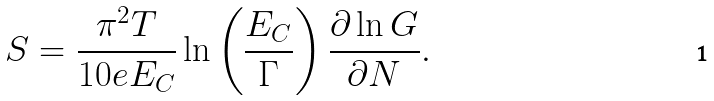<formula> <loc_0><loc_0><loc_500><loc_500>S = \frac { \pi ^ { 2 } T } { 1 0 e E _ { C } } \ln \left ( \frac { E _ { C } } { \Gamma } \right ) \frac { \partial \ln G } { \partial N } .</formula> 